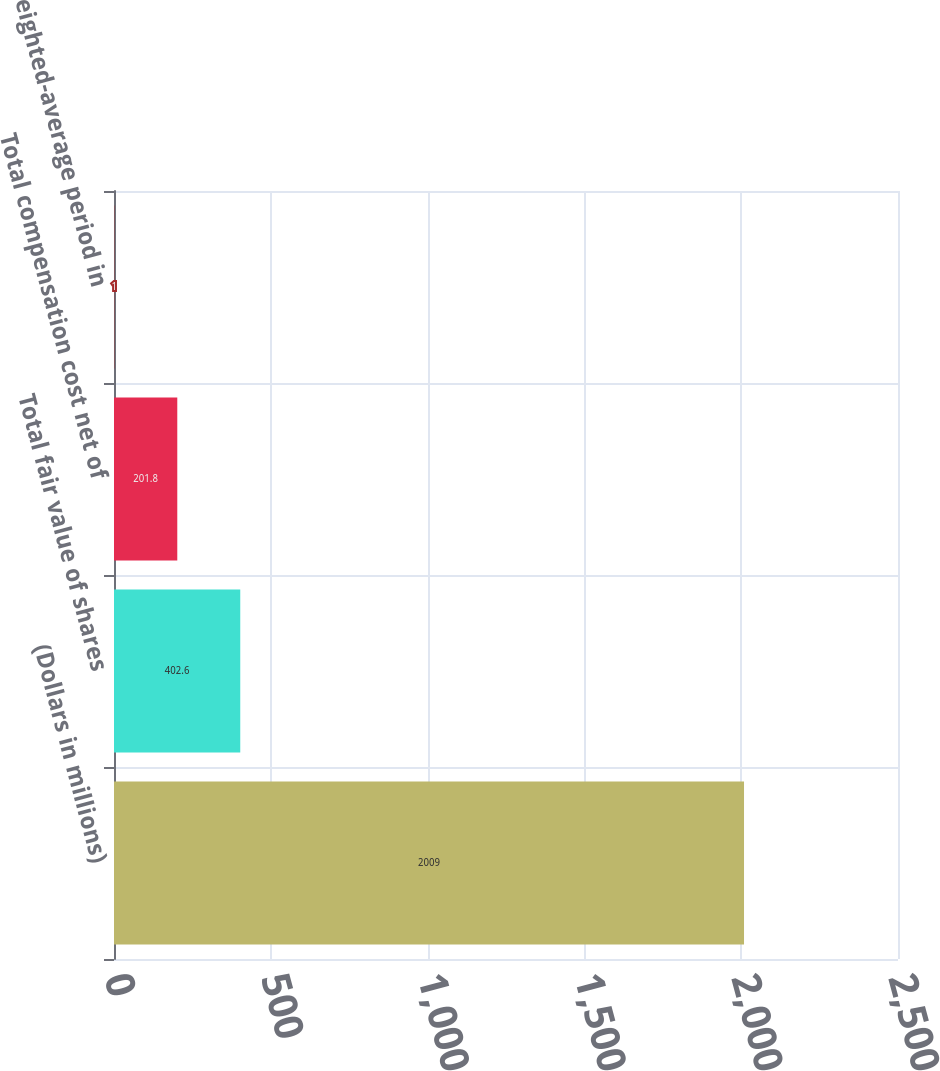<chart> <loc_0><loc_0><loc_500><loc_500><bar_chart><fcel>(Dollars in millions)<fcel>Total fair value of shares<fcel>Total compensation cost net of<fcel>Weighted-average period in<nl><fcel>2009<fcel>402.6<fcel>201.8<fcel>1<nl></chart> 